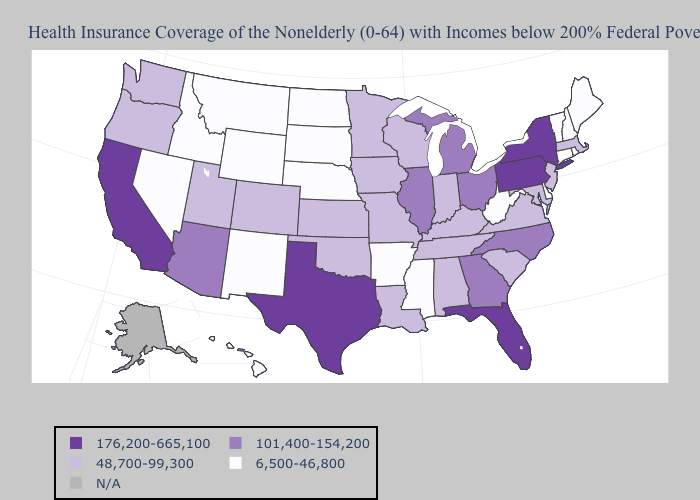What is the value of Hawaii?
Concise answer only. 6,500-46,800. What is the highest value in the USA?
Write a very short answer. 176,200-665,100. What is the highest value in the USA?
Quick response, please. 176,200-665,100. What is the value of Colorado?
Keep it brief. 48,700-99,300. Which states have the highest value in the USA?
Concise answer only. California, Florida, New York, Pennsylvania, Texas. What is the highest value in states that border Montana?
Answer briefly. 6,500-46,800. Does New York have the highest value in the USA?
Quick response, please. Yes. What is the lowest value in the USA?
Quick response, please. 6,500-46,800. Name the states that have a value in the range 176,200-665,100?
Quick response, please. California, Florida, New York, Pennsylvania, Texas. Name the states that have a value in the range 48,700-99,300?
Give a very brief answer. Alabama, Colorado, Indiana, Iowa, Kansas, Kentucky, Louisiana, Maryland, Massachusetts, Minnesota, Missouri, New Jersey, Oklahoma, Oregon, South Carolina, Tennessee, Utah, Virginia, Washington, Wisconsin. Among the states that border Rhode Island , does Massachusetts have the highest value?
Concise answer only. Yes. What is the value of North Carolina?
Answer briefly. 101,400-154,200. Name the states that have a value in the range N/A?
Answer briefly. Alaska. 